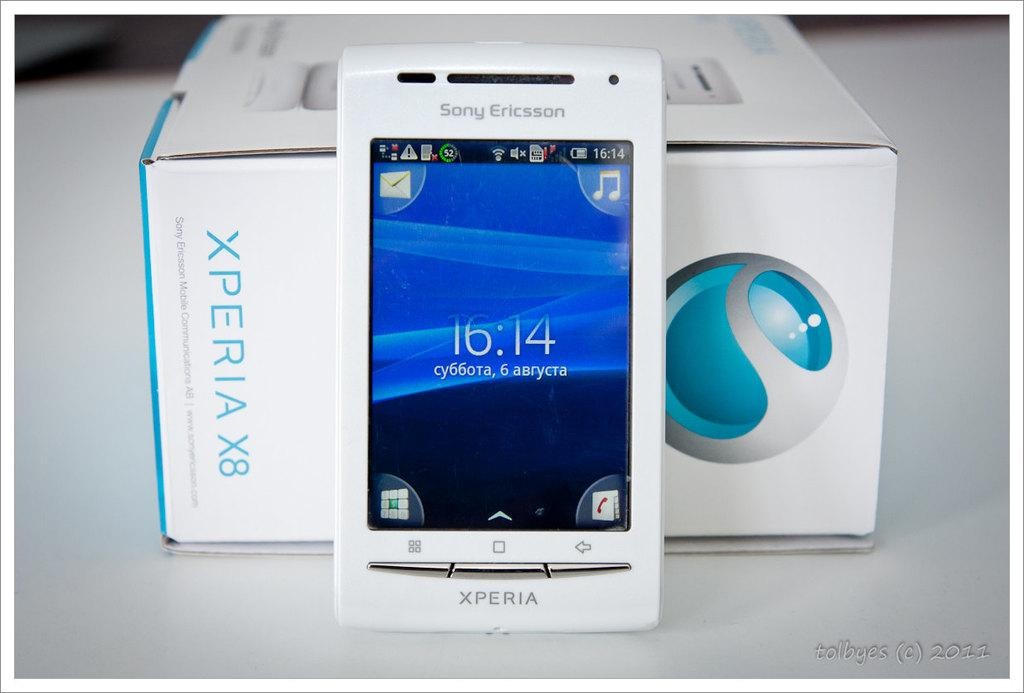<image>
Describe the image concisely. An Xperia smartphone by Sony Ericsson is displayed next to its box. 